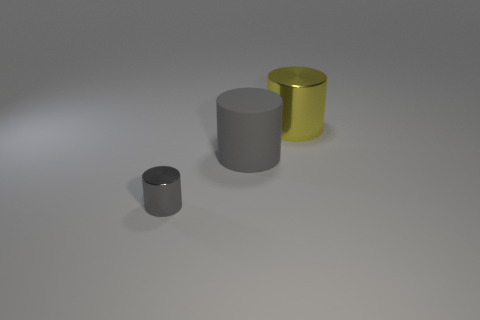Is there any other thing that is the same size as the gray metallic cylinder?
Give a very brief answer. No. There is a tiny object that is the same color as the big matte cylinder; what is it made of?
Give a very brief answer. Metal. There is a gray object that is the same size as the yellow object; what is it made of?
Your answer should be very brief. Rubber. Are there any gray cylinders that have the same size as the rubber object?
Provide a short and direct response. No. Does the large yellow metallic thing have the same shape as the small object?
Provide a short and direct response. Yes. Is there a big yellow metallic thing that is in front of the shiny object in front of the large object left of the yellow metallic cylinder?
Provide a short and direct response. No. How many other objects are there of the same color as the large metallic thing?
Ensure brevity in your answer.  0. There is a gray object behind the small shiny thing; does it have the same size as the metallic thing that is behind the small gray metallic cylinder?
Offer a terse response. Yes. Is the number of big yellow cylinders behind the large yellow object the same as the number of gray rubber cylinders that are on the left side of the big matte cylinder?
Your response must be concise. Yes. Is there any other thing that has the same material as the big gray cylinder?
Your answer should be very brief. No. 